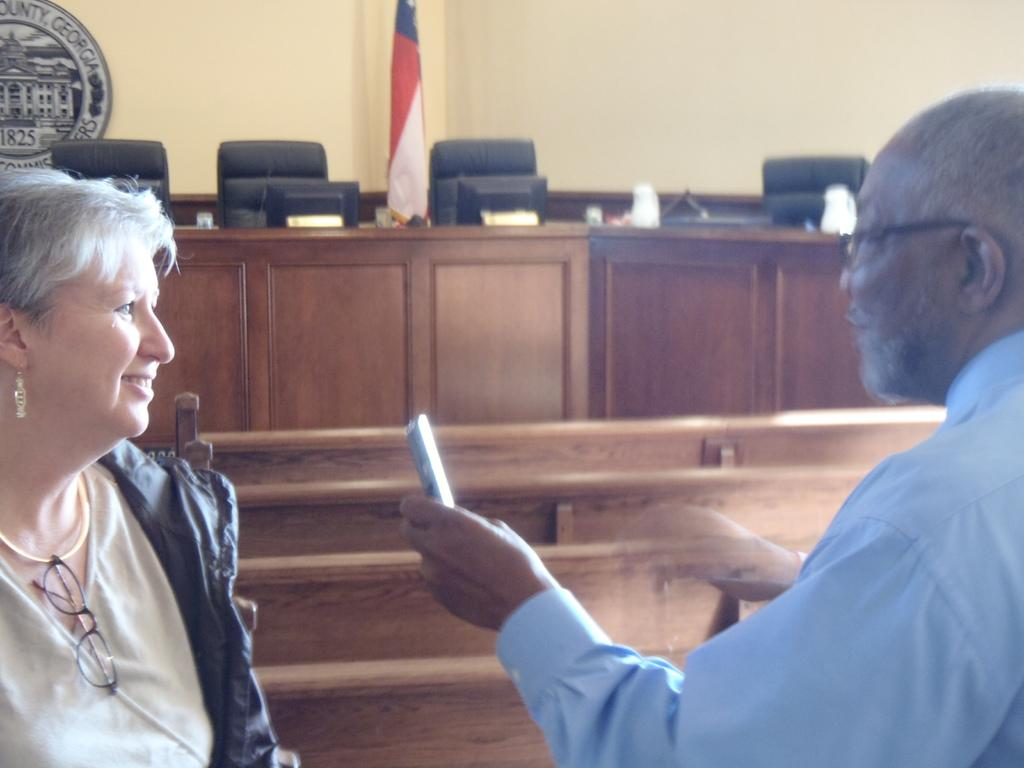How many people are present in the image? There is a woman and a man present in the image. What objects can be seen in the image that might be used for sitting? There are chairs in the image that can be used for sitting. What type of electronic devices are visible in the image? There are monitors in the image. What can be seen in the background of the image? There is a wall and a flag in the background of the image. Where is the kitten hiding with the sack in the image? There is no kitten or sack present in the image. What type of umbrella is being used by the man in the image? There is no umbrella visible in the image. 